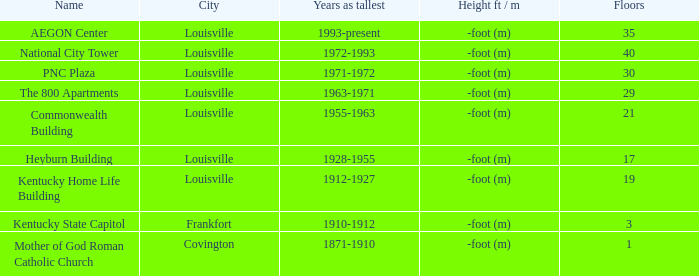What building in Louisville had more than 35 floors? National City Tower. 